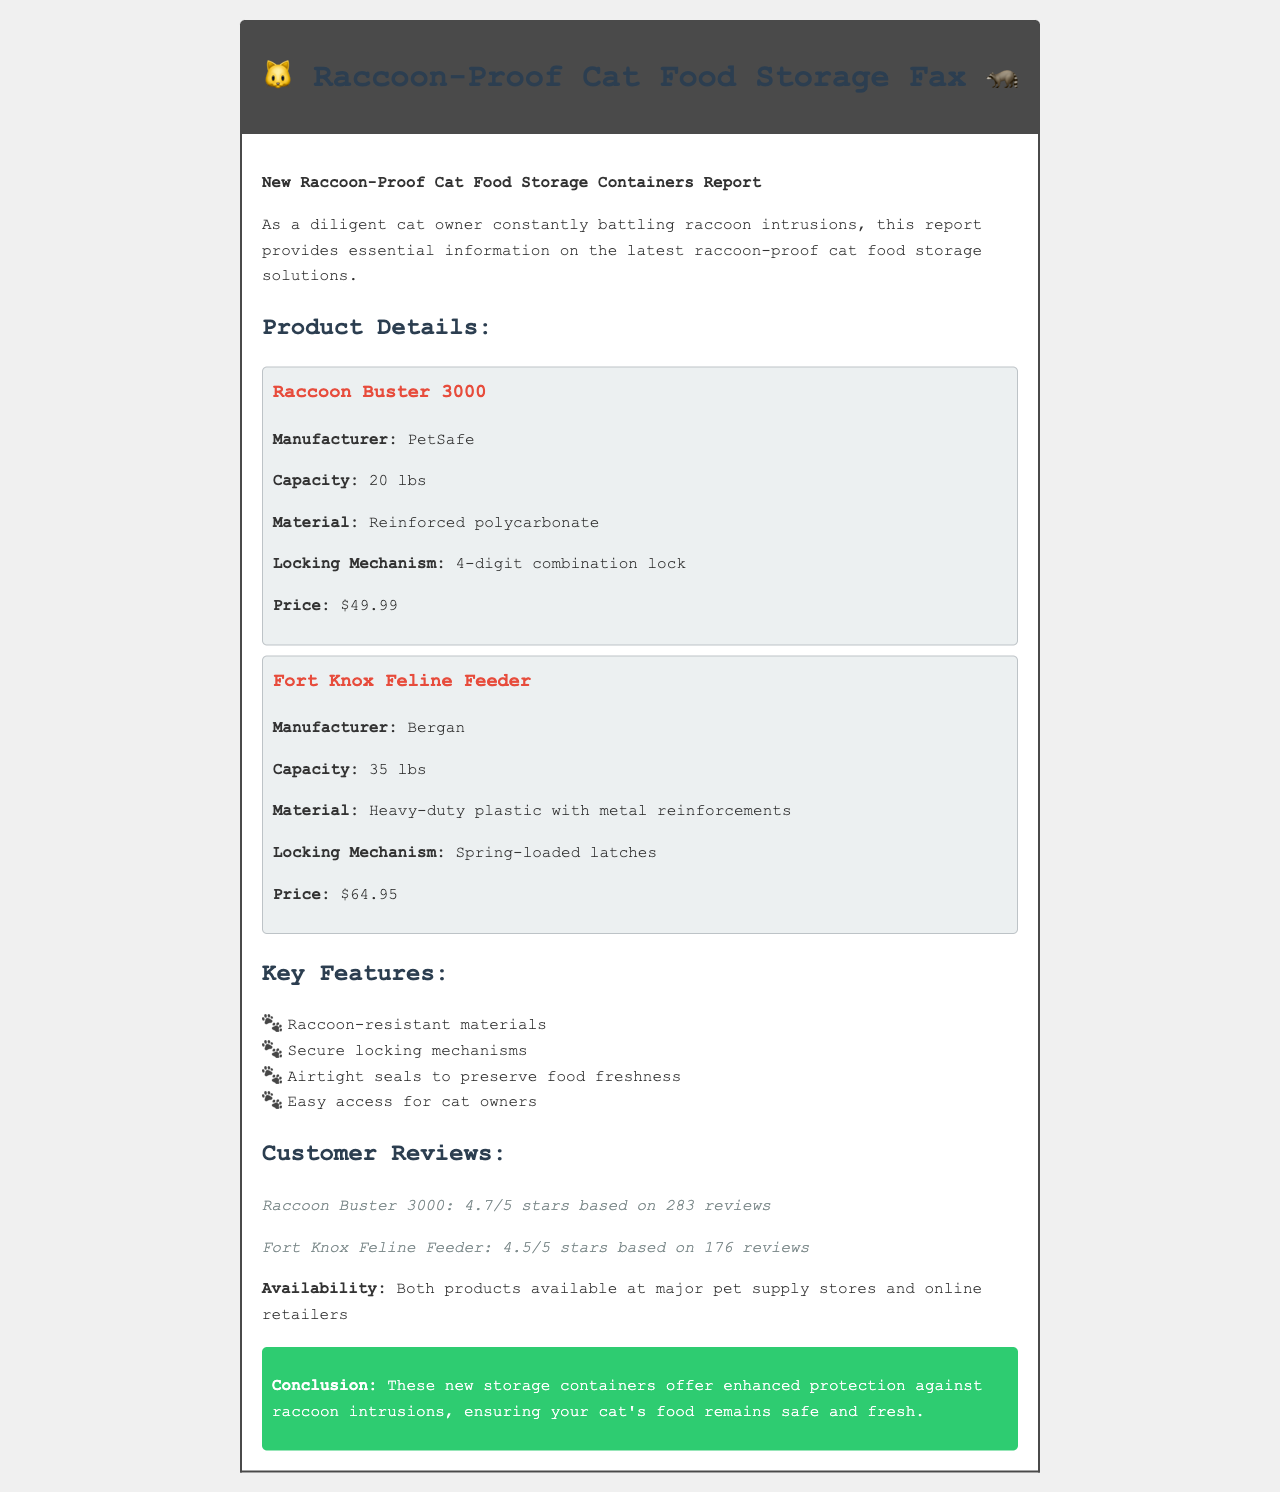what is the capacity of the Raccoon Buster 3000? The capacity of the Raccoon Buster 3000 is mentioned as 20 lbs in the product details.
Answer: 20 lbs who is the manufacturer of the Fort Knox Feline Feeder? The manufacturer of the Fort Knox Feline Feeder is specified in the document as Bergan.
Answer: Bergan what is the price of the Raccoon Buster 3000? The price of the Raccoon Buster 3000 is stated as $49.99 in the product details.
Answer: $49.99 which material is used in the Fort Knox Feline Feeder? The material used in the Fort Knox Feline Feeder is described as heavy-duty plastic with metal reinforcements in the document.
Answer: Heavy-duty plastic with metal reinforcements how many reviews does the Raccoon Buster 3000 have? The document states that the Raccoon Buster 3000 has 283 reviews total.
Answer: 283 what are the key features mentioned in the document? The list of key features can be found in the document, which includes raccoon-resistant materials, secure locking mechanisms, airtight seals to preserve food freshness, and easy access for cat owners.
Answer: Raccoon-resistant materials, secure locking mechanisms, airtight seals to preserve food freshness, easy access for cat owners what is the conclusion provided in the report? The conclusion summarizes the benefits of the storage containers against raccoon intrusions, ensuring safe and fresh cat food.
Answer: These new storage containers offer enhanced protection against raccoon intrusions, ensuring your cat's food remains safe and fresh how many stars does the Fort Knox Feline Feeder have? The Fort Knox Feline Feeder's rating is provided in the document as 4.5 stars based on 176 reviews.
Answer: 4.5 stars 